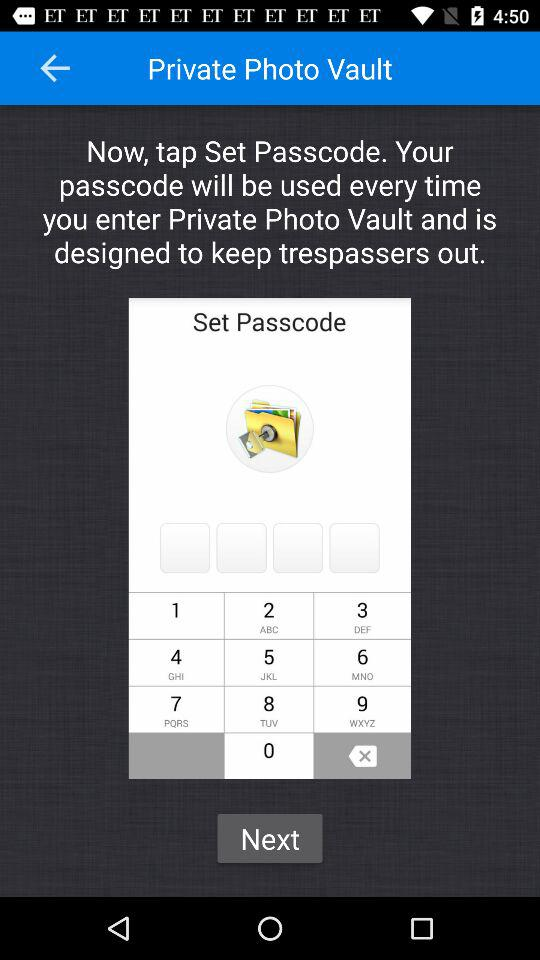What is the application name? The application name is "Private Photo Vault". 